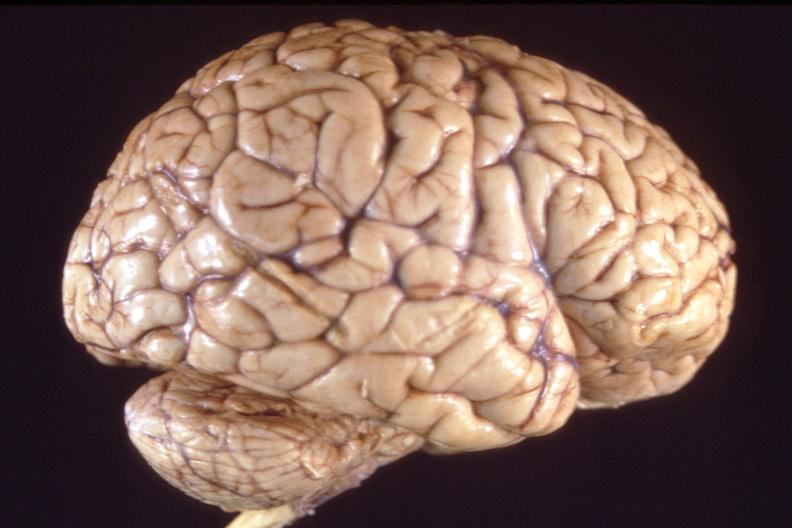s nervous present?
Answer the question using a single word or phrase. Yes 